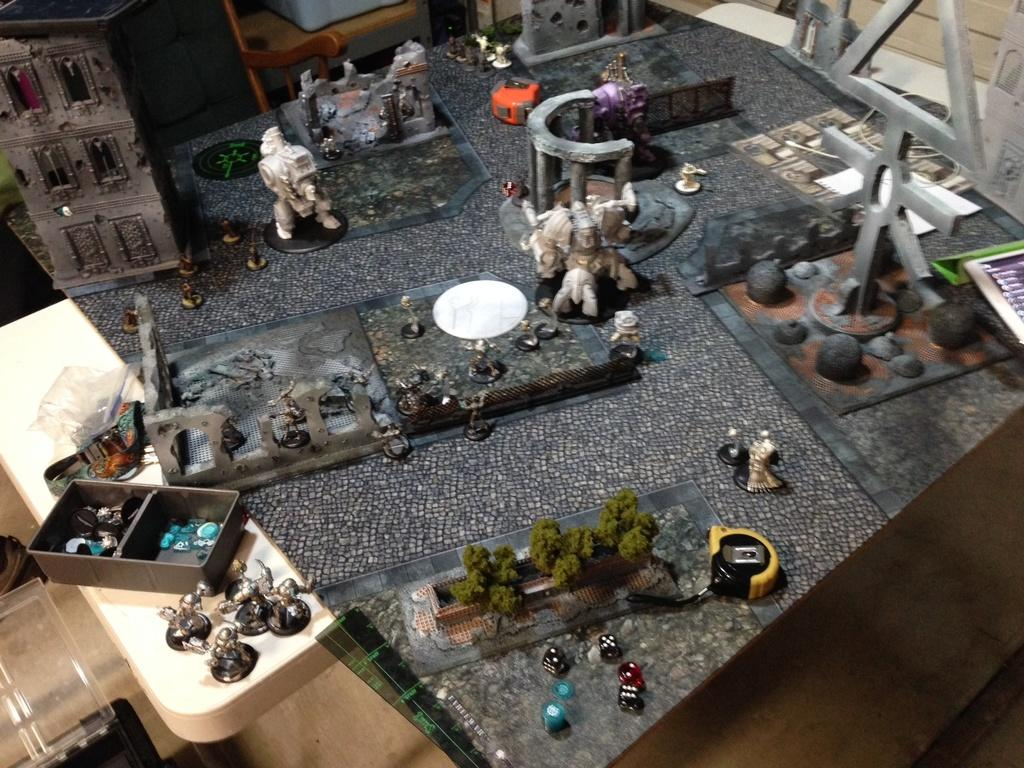What type of food can be seen in the image? There are sautes in the image. What type of natural elements are present in the image? There are trees in the image. What type of materials are used for the objects in the image? There are metal objects in the image. What type of objects can be seen in the background of the image? There are wooden objects in the background of the image. What type of education can be seen in the image? There is no reference to education in the image; it features sautes, trees, metal objects, and wooden objects in the background. 